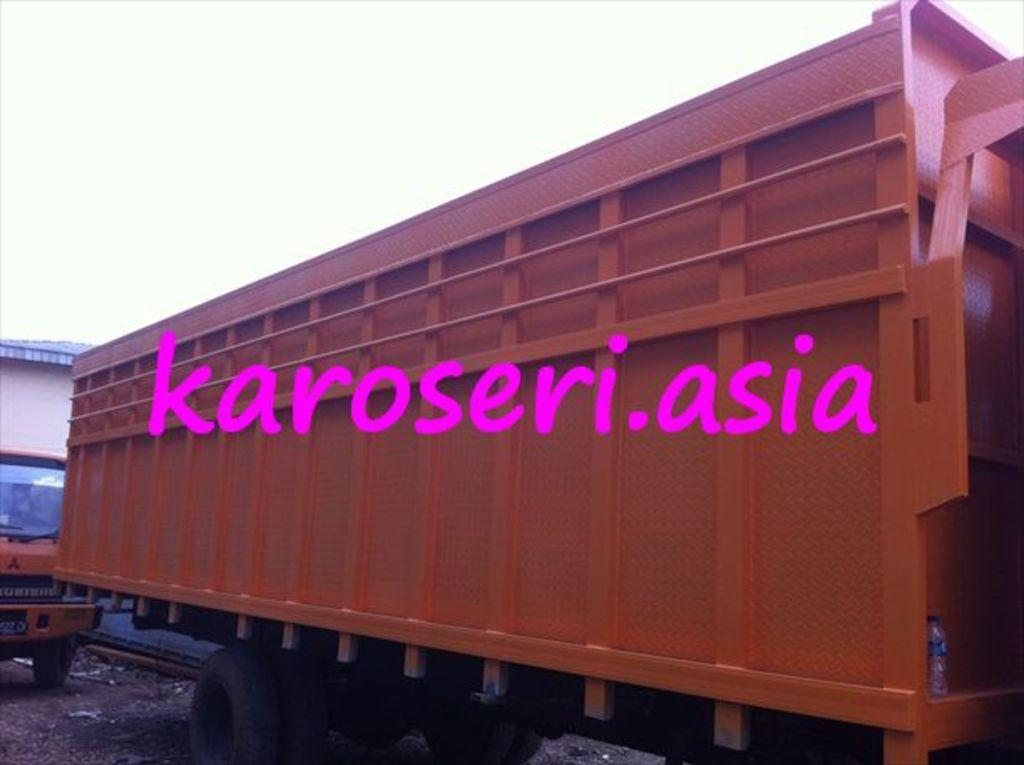What is the main subject of the image? The main subject of the image is vehicles. Are there any words or letters in the image? Yes, there is text written on the image. How would you describe the weather in the image? The sky is cloudy in the image, which suggests a potentially overcast or cloudy day. What type of shoes is the fireman wearing in the image? There is no fireman present in the image, so it is not possible to determine the type of shoes they might be wearing. 